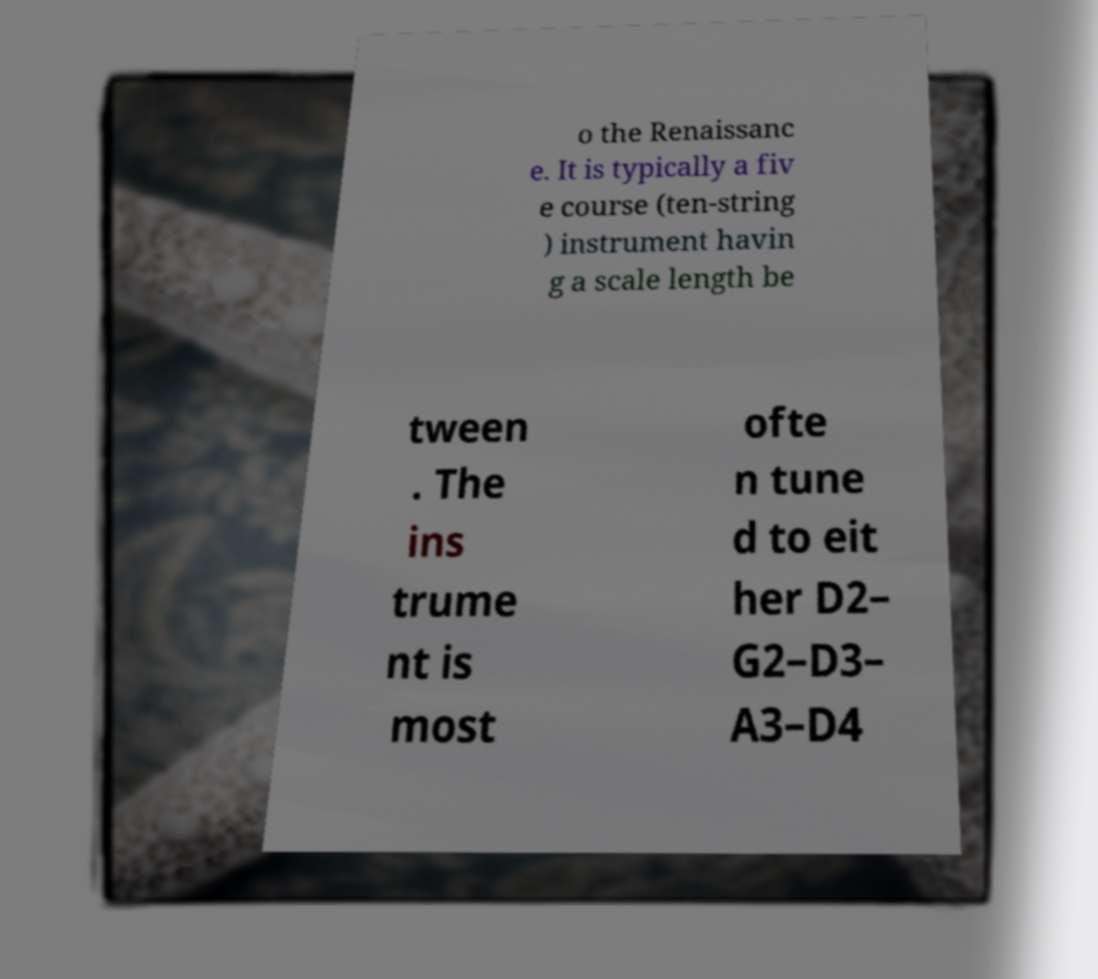What messages or text are displayed in this image? I need them in a readable, typed format. o the Renaissanc e. It is typically a fiv e course (ten-string ) instrument havin g a scale length be tween . The ins trume nt is most ofte n tune d to eit her D2– G2–D3– A3–D4 